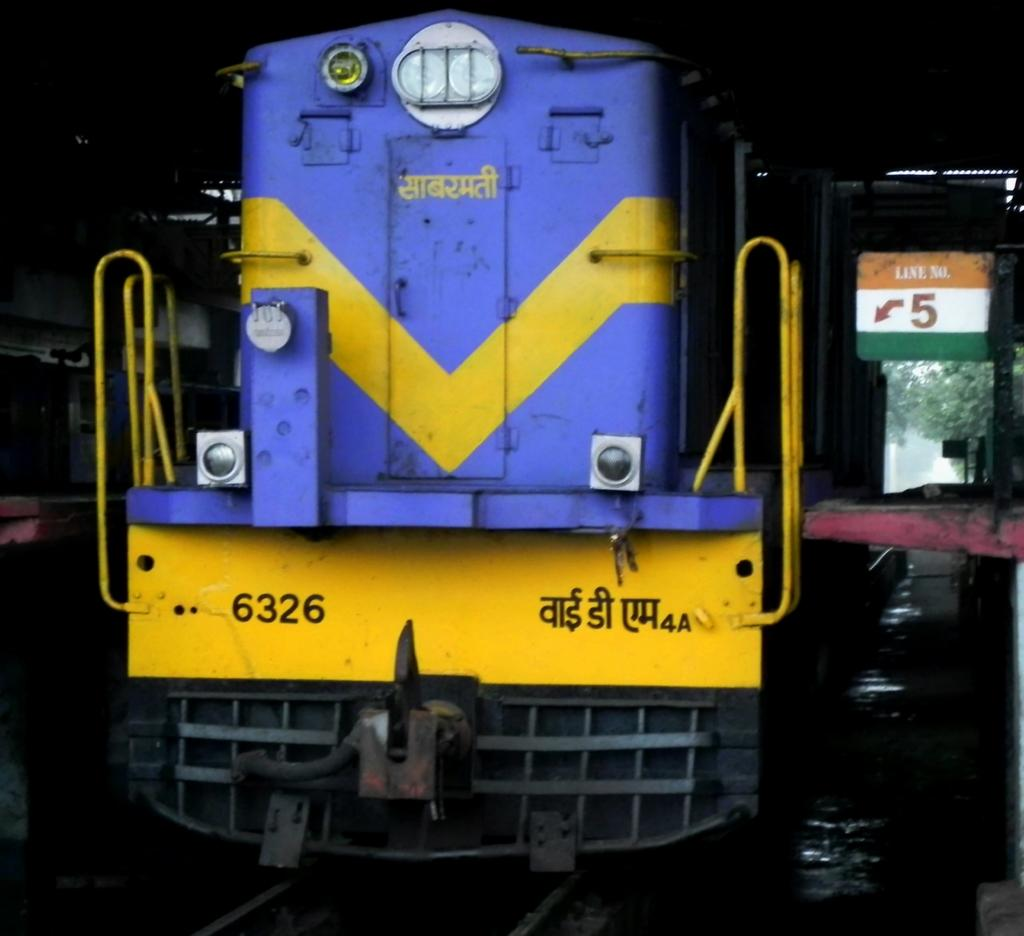What is the main subject of the image? The main subject of the image is a train on the track. What is located to the right of the train? There is a board to the right of the train. What can be seen in the background of the image? Trees are visible in the background of the image. What type of eggnog is being served to the pets in the image? There is no eggnog or pets present in the image; it features a train on a track with a board to the right and trees in the background. 